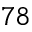<formula> <loc_0><loc_0><loc_500><loc_500>7 8</formula> 